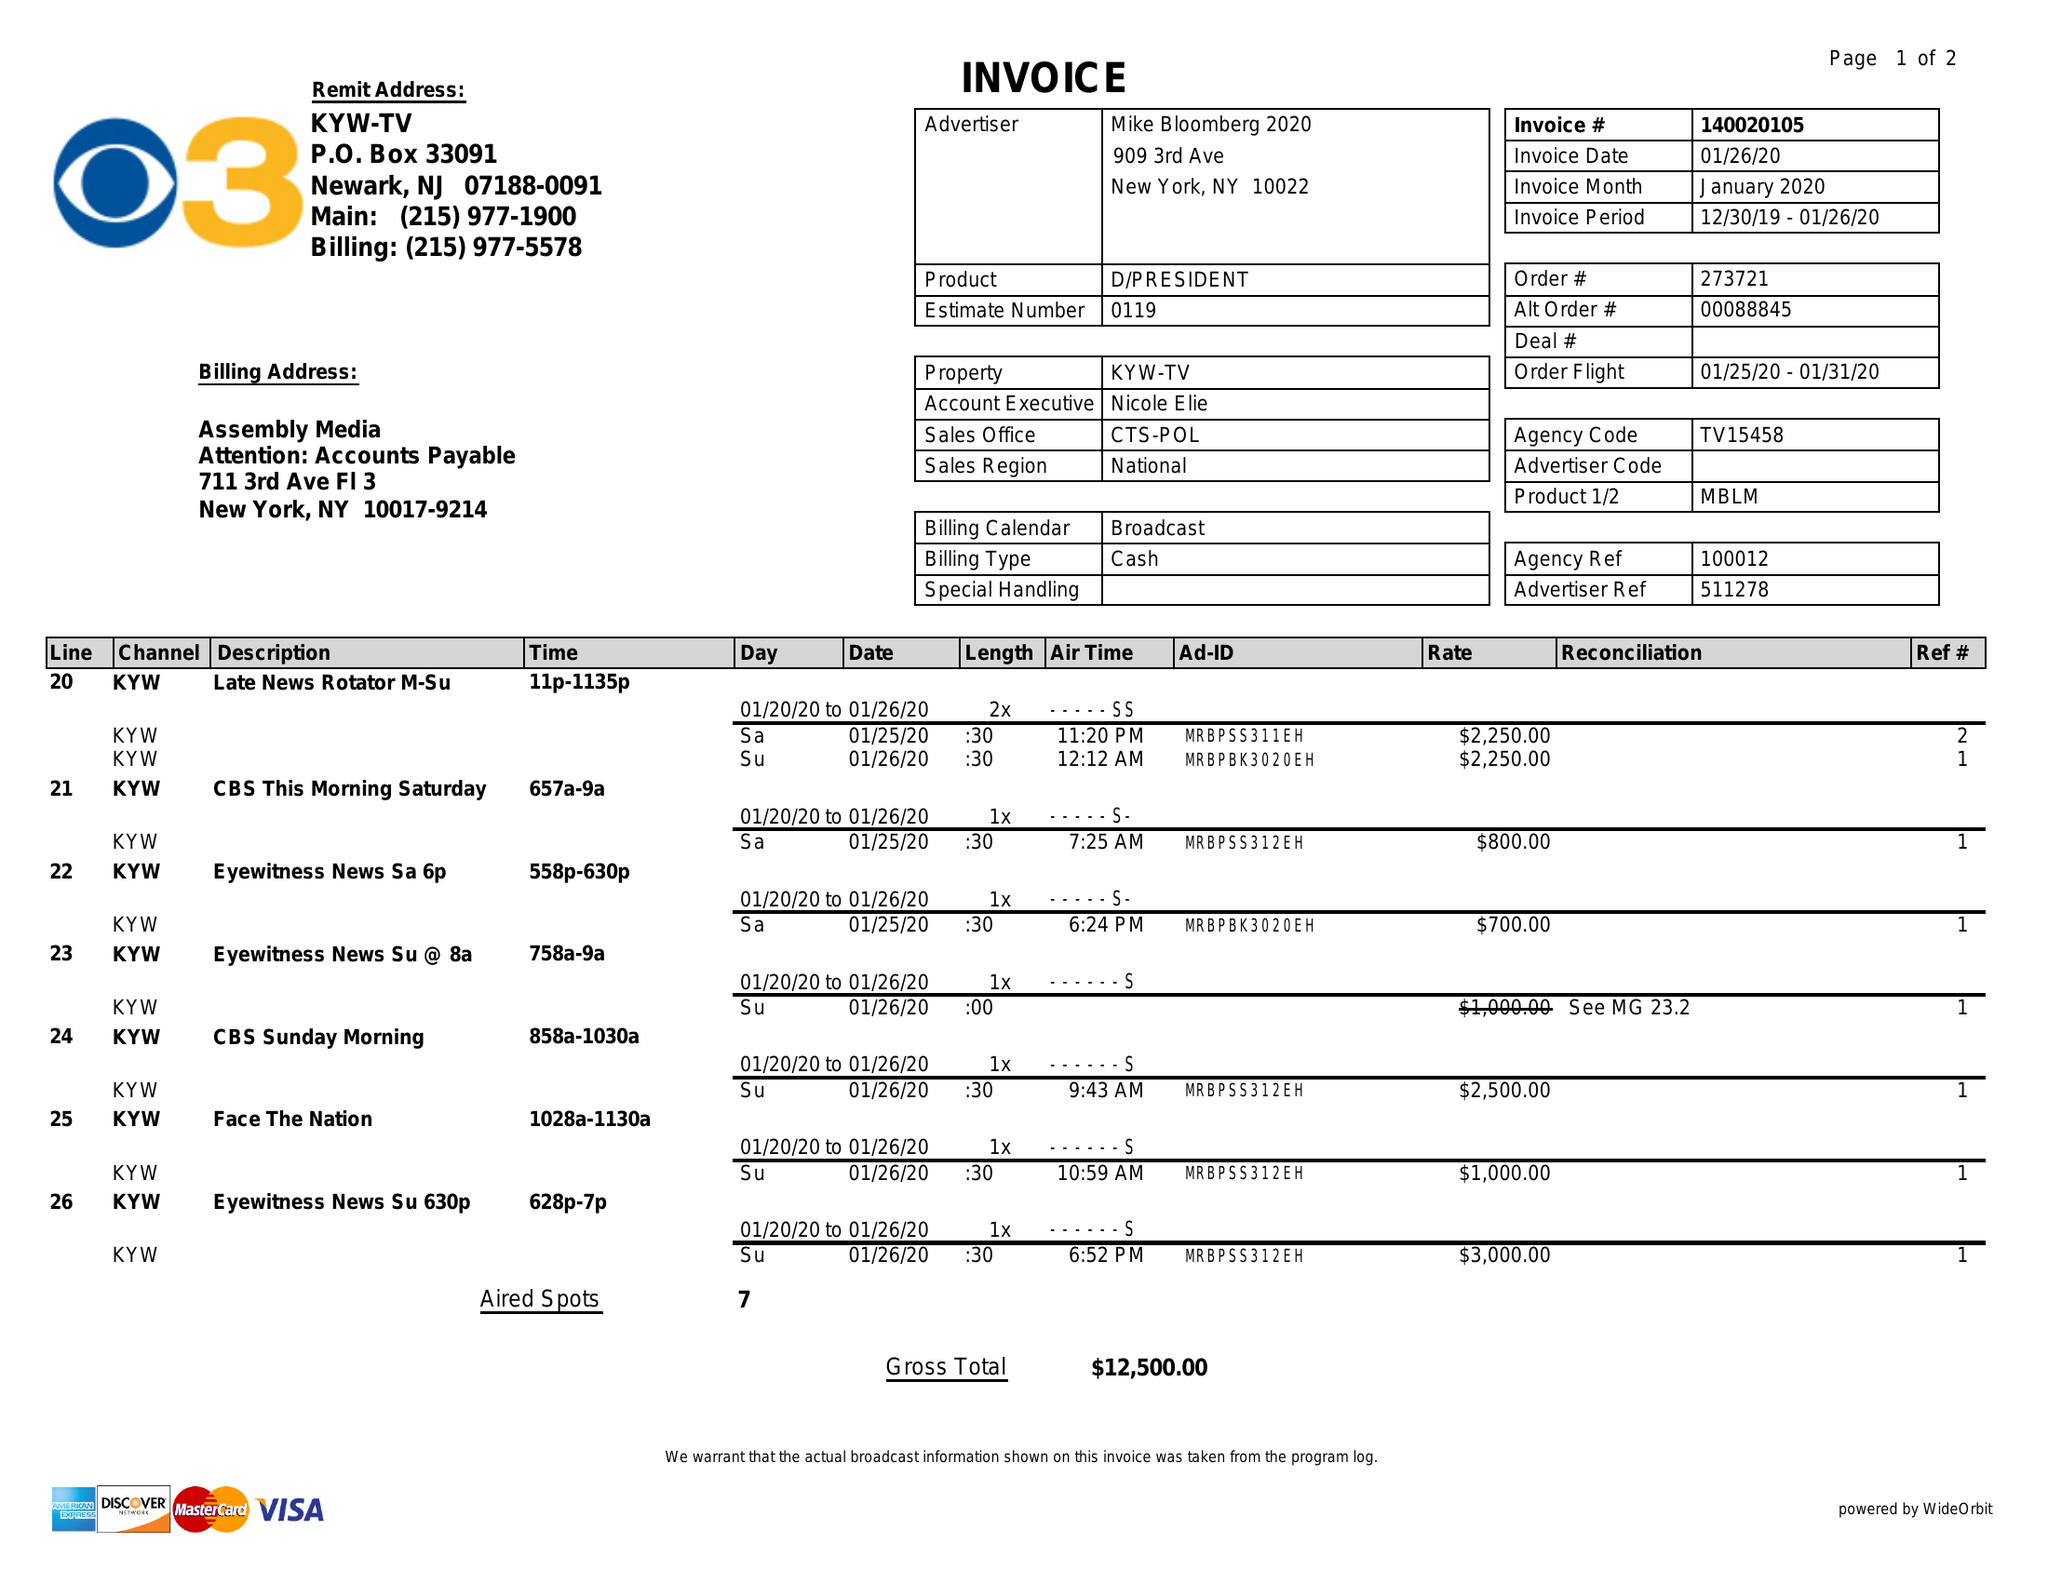What is the value for the advertiser?
Answer the question using a single word or phrase. MIKE BLOOMBERG 2020 